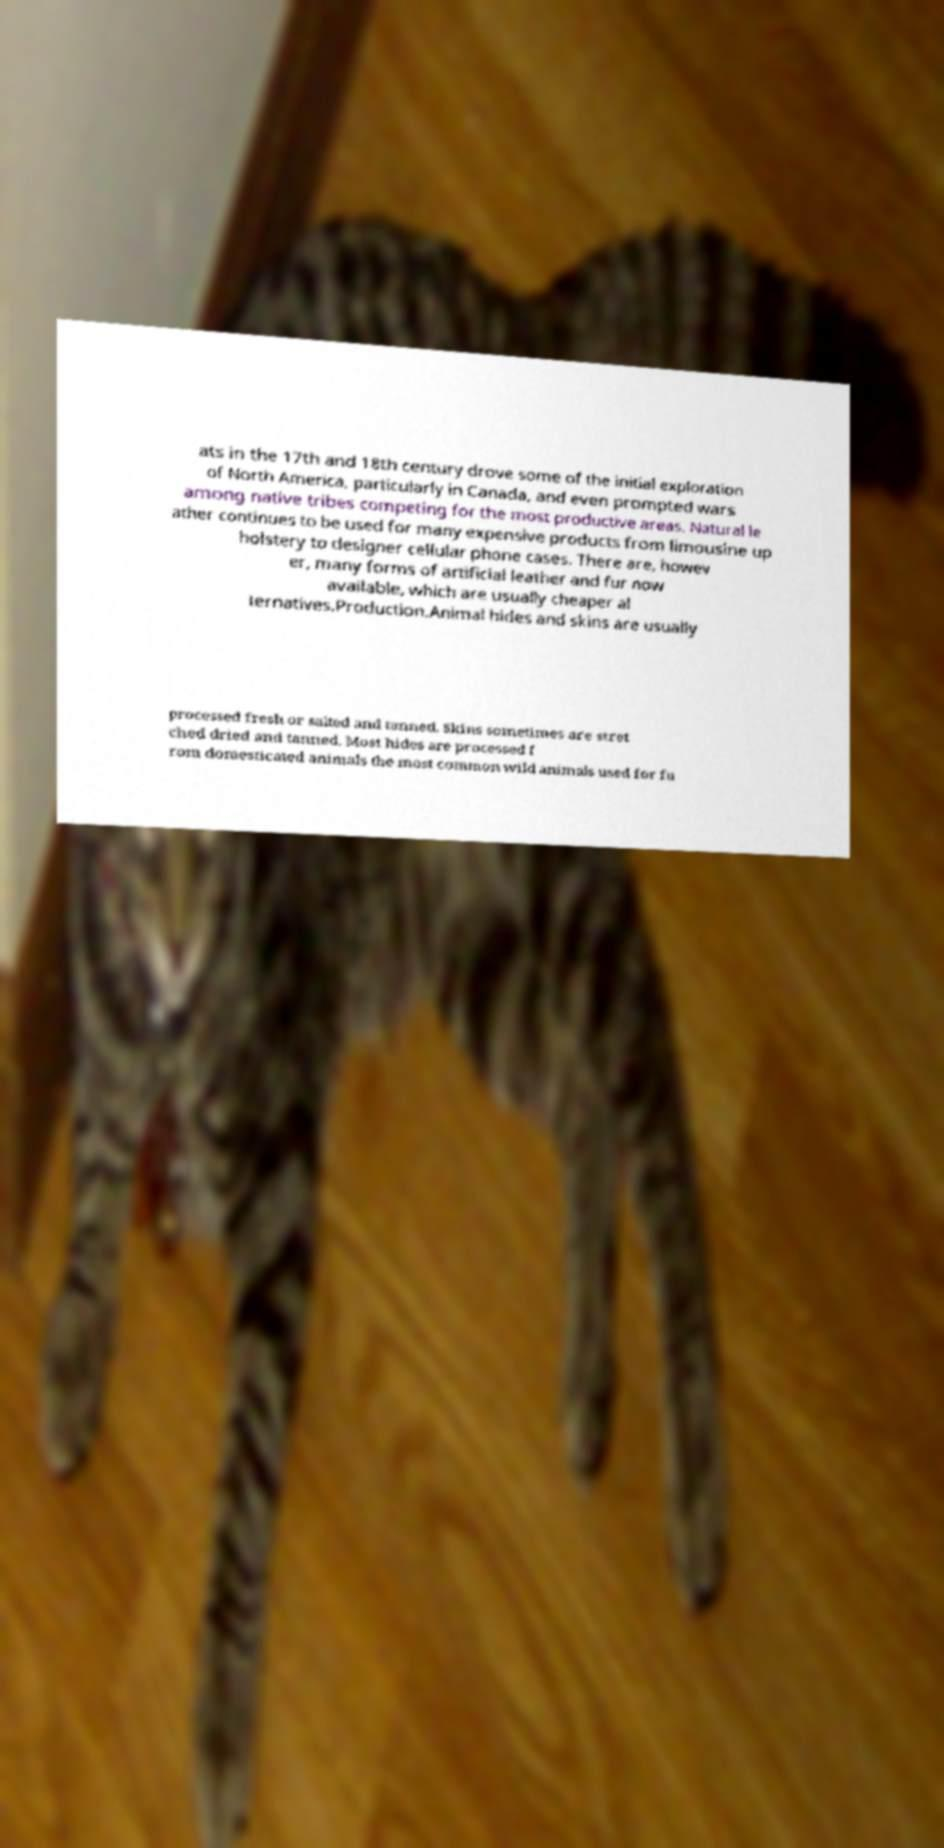Could you extract and type out the text from this image? ats in the 17th and 18th century drove some of the initial exploration of North America, particularly in Canada, and even prompted wars among native tribes competing for the most productive areas. Natural le ather continues to be used for many expensive products from limousine up holstery to designer cellular phone cases. There are, howev er, many forms of artificial leather and fur now available, which are usually cheaper al ternatives.Production.Animal hides and skins are usually processed fresh or salted and tanned. Skins sometimes are stret ched dried and tanned. Most hides are processed f rom domesticated animals the most common wild animals used for fu 